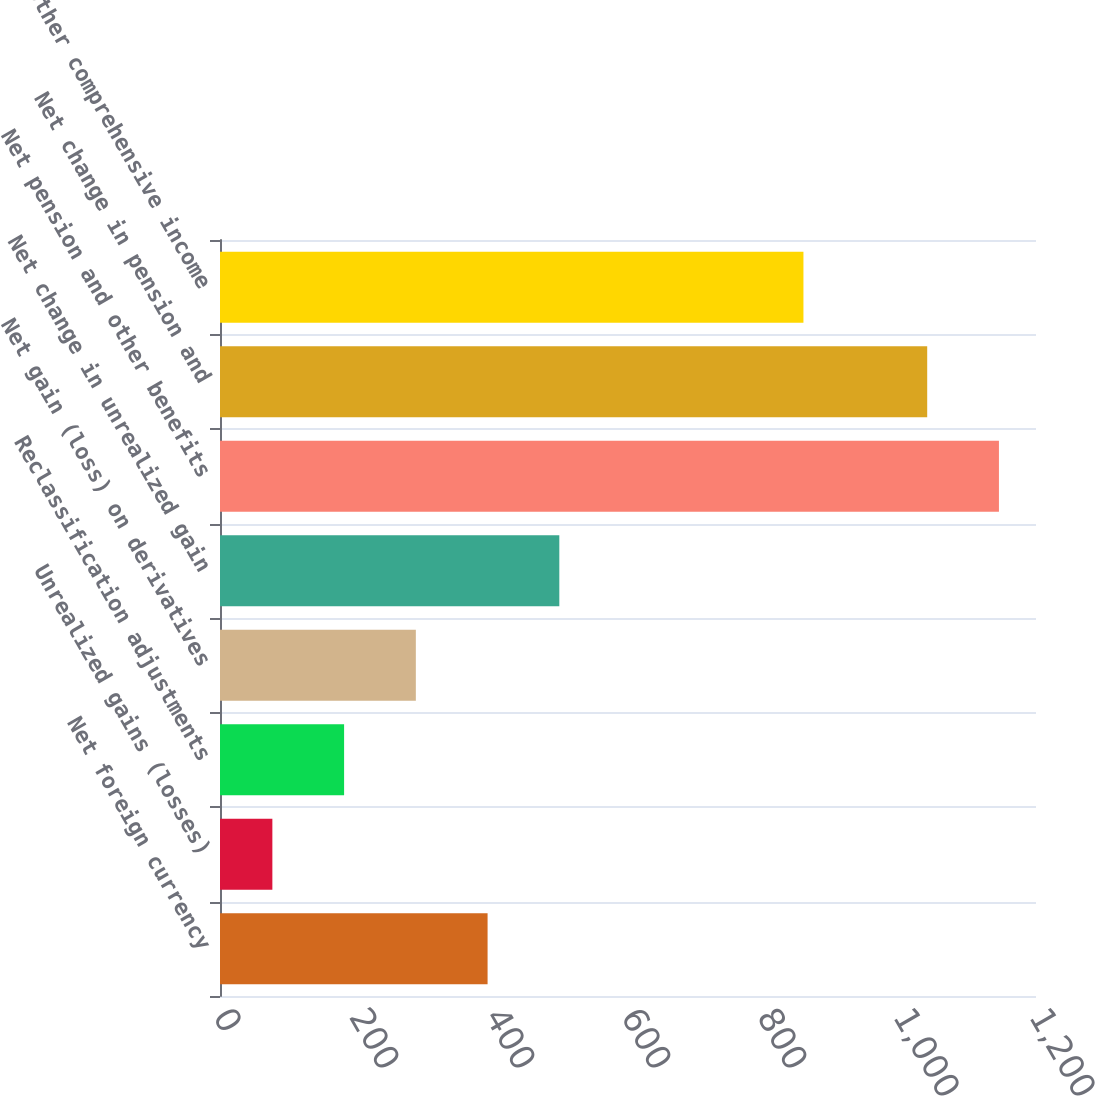<chart> <loc_0><loc_0><loc_500><loc_500><bar_chart><fcel>Net foreign currency<fcel>Unrealized gains (losses)<fcel>Reclassification adjustments<fcel>Net gain (loss) on derivatives<fcel>Net change in unrealized gain<fcel>Net pension and other benefits<fcel>Net change in pension and<fcel>Other comprehensive income<nl><fcel>393.5<fcel>77<fcel>182.5<fcel>288<fcel>499<fcel>1145.5<fcel>1040<fcel>858<nl></chart> 